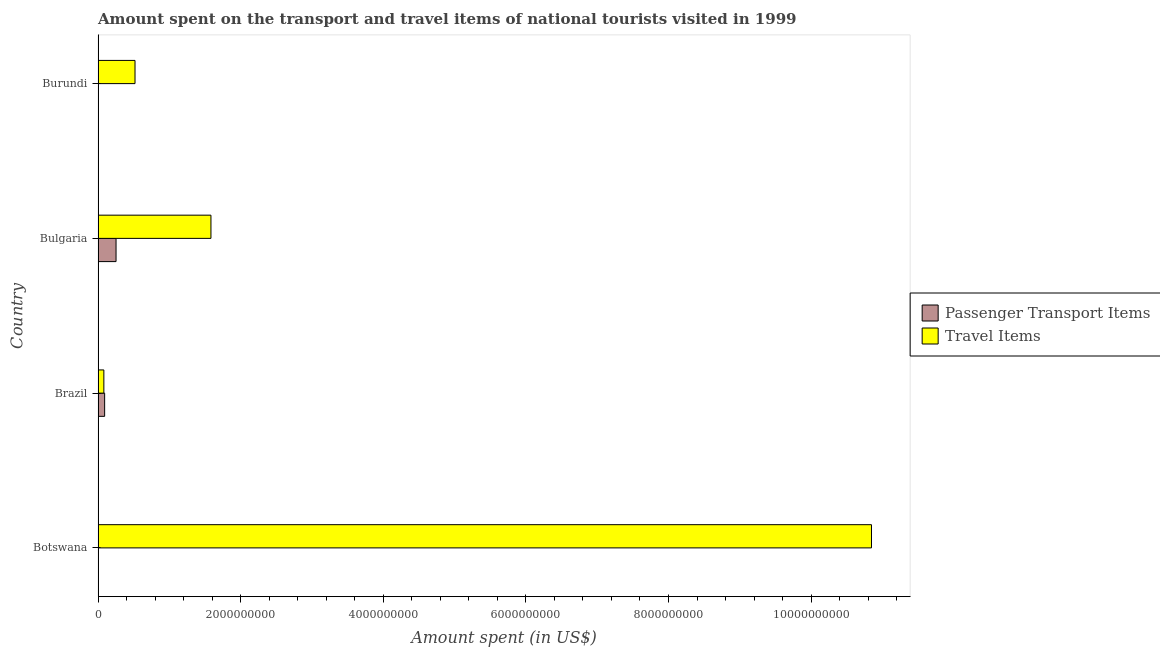How many different coloured bars are there?
Keep it short and to the point. 2. How many groups of bars are there?
Offer a terse response. 4. How many bars are there on the 4th tick from the top?
Provide a succinct answer. 2. What is the amount spent in travel items in Botswana?
Your answer should be compact. 1.08e+1. Across all countries, what is the maximum amount spent on passenger transport items?
Give a very brief answer. 2.52e+08. Across all countries, what is the minimum amount spent in travel items?
Offer a terse response. 8.10e+07. In which country was the amount spent on passenger transport items maximum?
Your answer should be compact. Bulgaria. In which country was the amount spent on passenger transport items minimum?
Provide a short and direct response. Burundi. What is the total amount spent on passenger transport items in the graph?
Make the answer very short. 3.50e+08. What is the difference between the amount spent on passenger transport items in Botswana and that in Brazil?
Make the answer very short. -8.70e+07. What is the difference between the amount spent on passenger transport items in Botswana and the amount spent in travel items in Brazil?
Offer a terse response. -7.60e+07. What is the average amount spent on passenger transport items per country?
Give a very brief answer. 8.74e+07. What is the difference between the amount spent in travel items and amount spent on passenger transport items in Burundi?
Your response must be concise. 5.18e+08. In how many countries, is the amount spent on passenger transport items greater than 4800000000 US$?
Ensure brevity in your answer.  0. What is the ratio of the amount spent in travel items in Brazil to that in Bulgaria?
Keep it short and to the point. 0.05. Is the amount spent in travel items in Brazil less than that in Burundi?
Your response must be concise. Yes. Is the difference between the amount spent in travel items in Botswana and Bulgaria greater than the difference between the amount spent on passenger transport items in Botswana and Bulgaria?
Your answer should be very brief. Yes. What is the difference between the highest and the second highest amount spent in travel items?
Your answer should be very brief. 9.26e+09. What is the difference between the highest and the lowest amount spent on passenger transport items?
Provide a succinct answer. 2.52e+08. Is the sum of the amount spent in travel items in Botswana and Brazil greater than the maximum amount spent on passenger transport items across all countries?
Your response must be concise. Yes. What does the 2nd bar from the top in Brazil represents?
Keep it short and to the point. Passenger Transport Items. What does the 2nd bar from the bottom in Bulgaria represents?
Your answer should be compact. Travel Items. How many bars are there?
Keep it short and to the point. 8. Are all the bars in the graph horizontal?
Your response must be concise. Yes. How many countries are there in the graph?
Keep it short and to the point. 4. Where does the legend appear in the graph?
Keep it short and to the point. Center right. How many legend labels are there?
Your answer should be very brief. 2. How are the legend labels stacked?
Offer a very short reply. Vertical. What is the title of the graph?
Your answer should be compact. Amount spent on the transport and travel items of national tourists visited in 1999. Does "Travel Items" appear as one of the legend labels in the graph?
Your response must be concise. Yes. What is the label or title of the X-axis?
Offer a very short reply. Amount spent (in US$). What is the Amount spent (in US$) in Passenger Transport Items in Botswana?
Keep it short and to the point. 5.00e+06. What is the Amount spent (in US$) in Travel Items in Botswana?
Give a very brief answer. 1.08e+1. What is the Amount spent (in US$) of Passenger Transport Items in Brazil?
Make the answer very short. 9.20e+07. What is the Amount spent (in US$) of Travel Items in Brazil?
Provide a succinct answer. 8.10e+07. What is the Amount spent (in US$) of Passenger Transport Items in Bulgaria?
Your answer should be very brief. 2.52e+08. What is the Amount spent (in US$) of Travel Items in Bulgaria?
Offer a terse response. 1.58e+09. What is the Amount spent (in US$) of Passenger Transport Items in Burundi?
Your answer should be compact. 5.00e+05. What is the Amount spent (in US$) of Travel Items in Burundi?
Ensure brevity in your answer.  5.18e+08. Across all countries, what is the maximum Amount spent (in US$) in Passenger Transport Items?
Your response must be concise. 2.52e+08. Across all countries, what is the maximum Amount spent (in US$) in Travel Items?
Offer a very short reply. 1.08e+1. Across all countries, what is the minimum Amount spent (in US$) in Passenger Transport Items?
Your answer should be compact. 5.00e+05. Across all countries, what is the minimum Amount spent (in US$) in Travel Items?
Offer a very short reply. 8.10e+07. What is the total Amount spent (in US$) in Passenger Transport Items in the graph?
Offer a terse response. 3.50e+08. What is the total Amount spent (in US$) in Travel Items in the graph?
Provide a succinct answer. 1.30e+1. What is the difference between the Amount spent (in US$) in Passenger Transport Items in Botswana and that in Brazil?
Provide a succinct answer. -8.70e+07. What is the difference between the Amount spent (in US$) in Travel Items in Botswana and that in Brazil?
Your answer should be compact. 1.08e+1. What is the difference between the Amount spent (in US$) of Passenger Transport Items in Botswana and that in Bulgaria?
Offer a very short reply. -2.47e+08. What is the difference between the Amount spent (in US$) of Travel Items in Botswana and that in Bulgaria?
Give a very brief answer. 9.26e+09. What is the difference between the Amount spent (in US$) in Passenger Transport Items in Botswana and that in Burundi?
Your answer should be very brief. 4.50e+06. What is the difference between the Amount spent (in US$) of Travel Items in Botswana and that in Burundi?
Make the answer very short. 1.03e+1. What is the difference between the Amount spent (in US$) of Passenger Transport Items in Brazil and that in Bulgaria?
Provide a succinct answer. -1.60e+08. What is the difference between the Amount spent (in US$) of Travel Items in Brazil and that in Bulgaria?
Your response must be concise. -1.50e+09. What is the difference between the Amount spent (in US$) of Passenger Transport Items in Brazil and that in Burundi?
Your answer should be compact. 9.15e+07. What is the difference between the Amount spent (in US$) of Travel Items in Brazil and that in Burundi?
Give a very brief answer. -4.37e+08. What is the difference between the Amount spent (in US$) of Passenger Transport Items in Bulgaria and that in Burundi?
Provide a short and direct response. 2.52e+08. What is the difference between the Amount spent (in US$) of Travel Items in Bulgaria and that in Burundi?
Provide a short and direct response. 1.06e+09. What is the difference between the Amount spent (in US$) of Passenger Transport Items in Botswana and the Amount spent (in US$) of Travel Items in Brazil?
Provide a short and direct response. -7.60e+07. What is the difference between the Amount spent (in US$) of Passenger Transport Items in Botswana and the Amount spent (in US$) of Travel Items in Bulgaria?
Ensure brevity in your answer.  -1.58e+09. What is the difference between the Amount spent (in US$) of Passenger Transport Items in Botswana and the Amount spent (in US$) of Travel Items in Burundi?
Give a very brief answer. -5.13e+08. What is the difference between the Amount spent (in US$) in Passenger Transport Items in Brazil and the Amount spent (in US$) in Travel Items in Bulgaria?
Your answer should be very brief. -1.49e+09. What is the difference between the Amount spent (in US$) of Passenger Transport Items in Brazil and the Amount spent (in US$) of Travel Items in Burundi?
Offer a terse response. -4.26e+08. What is the difference between the Amount spent (in US$) in Passenger Transport Items in Bulgaria and the Amount spent (in US$) in Travel Items in Burundi?
Provide a succinct answer. -2.66e+08. What is the average Amount spent (in US$) of Passenger Transport Items per country?
Offer a very short reply. 8.74e+07. What is the average Amount spent (in US$) of Travel Items per country?
Offer a terse response. 3.26e+09. What is the difference between the Amount spent (in US$) of Passenger Transport Items and Amount spent (in US$) of Travel Items in Botswana?
Provide a succinct answer. -1.08e+1. What is the difference between the Amount spent (in US$) of Passenger Transport Items and Amount spent (in US$) of Travel Items in Brazil?
Provide a succinct answer. 1.10e+07. What is the difference between the Amount spent (in US$) of Passenger Transport Items and Amount spent (in US$) of Travel Items in Bulgaria?
Your answer should be compact. -1.33e+09. What is the difference between the Amount spent (in US$) of Passenger Transport Items and Amount spent (in US$) of Travel Items in Burundi?
Keep it short and to the point. -5.18e+08. What is the ratio of the Amount spent (in US$) of Passenger Transport Items in Botswana to that in Brazil?
Offer a very short reply. 0.05. What is the ratio of the Amount spent (in US$) of Travel Items in Botswana to that in Brazil?
Your answer should be compact. 133.91. What is the ratio of the Amount spent (in US$) of Passenger Transport Items in Botswana to that in Bulgaria?
Provide a short and direct response. 0.02. What is the ratio of the Amount spent (in US$) of Travel Items in Botswana to that in Bulgaria?
Your answer should be very brief. 6.85. What is the ratio of the Amount spent (in US$) in Passenger Transport Items in Botswana to that in Burundi?
Offer a very short reply. 10. What is the ratio of the Amount spent (in US$) in Travel Items in Botswana to that in Burundi?
Your answer should be very brief. 20.94. What is the ratio of the Amount spent (in US$) in Passenger Transport Items in Brazil to that in Bulgaria?
Your response must be concise. 0.37. What is the ratio of the Amount spent (in US$) of Travel Items in Brazil to that in Bulgaria?
Your answer should be compact. 0.05. What is the ratio of the Amount spent (in US$) in Passenger Transport Items in Brazil to that in Burundi?
Offer a terse response. 184. What is the ratio of the Amount spent (in US$) of Travel Items in Brazil to that in Burundi?
Give a very brief answer. 0.16. What is the ratio of the Amount spent (in US$) in Passenger Transport Items in Bulgaria to that in Burundi?
Your response must be concise. 504. What is the ratio of the Amount spent (in US$) of Travel Items in Bulgaria to that in Burundi?
Give a very brief answer. 3.06. What is the difference between the highest and the second highest Amount spent (in US$) of Passenger Transport Items?
Keep it short and to the point. 1.60e+08. What is the difference between the highest and the second highest Amount spent (in US$) of Travel Items?
Your answer should be very brief. 9.26e+09. What is the difference between the highest and the lowest Amount spent (in US$) in Passenger Transport Items?
Ensure brevity in your answer.  2.52e+08. What is the difference between the highest and the lowest Amount spent (in US$) in Travel Items?
Ensure brevity in your answer.  1.08e+1. 